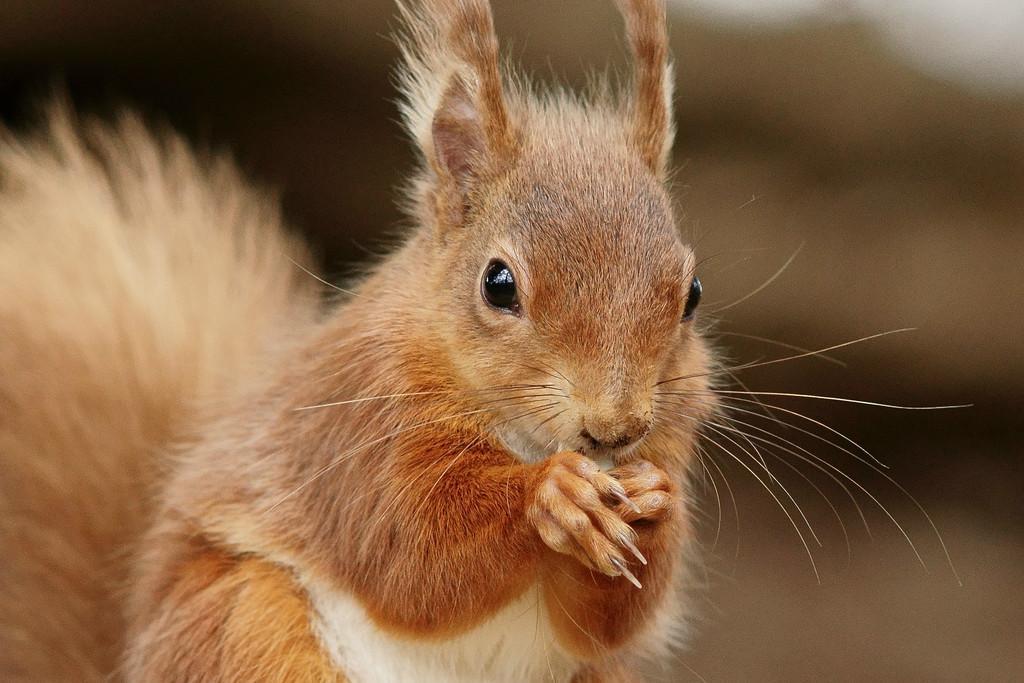Could you give a brief overview of what you see in this image? We can see squirrel. Background it is blur. 